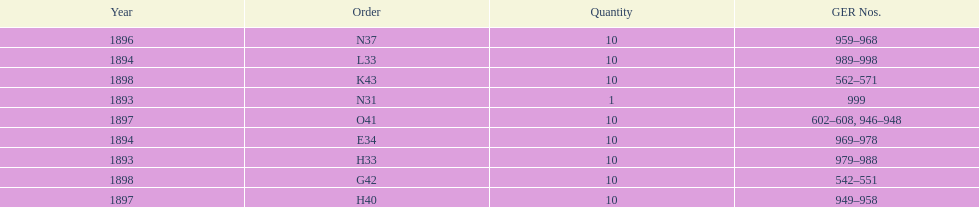Was the quantity higher in 1894 or 1893? 1894. 